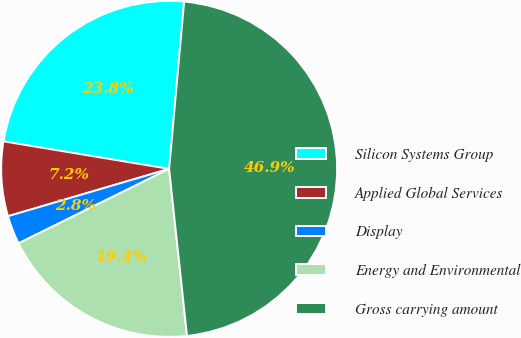Convert chart. <chart><loc_0><loc_0><loc_500><loc_500><pie_chart><fcel>Silicon Systems Group<fcel>Applied Global Services<fcel>Display<fcel>Energy and Environmental<fcel>Gross carrying amount<nl><fcel>23.8%<fcel>7.17%<fcel>2.76%<fcel>19.39%<fcel>46.88%<nl></chart> 